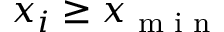<formula> <loc_0><loc_0><loc_500><loc_500>x _ { i } \geq x _ { \min }</formula> 